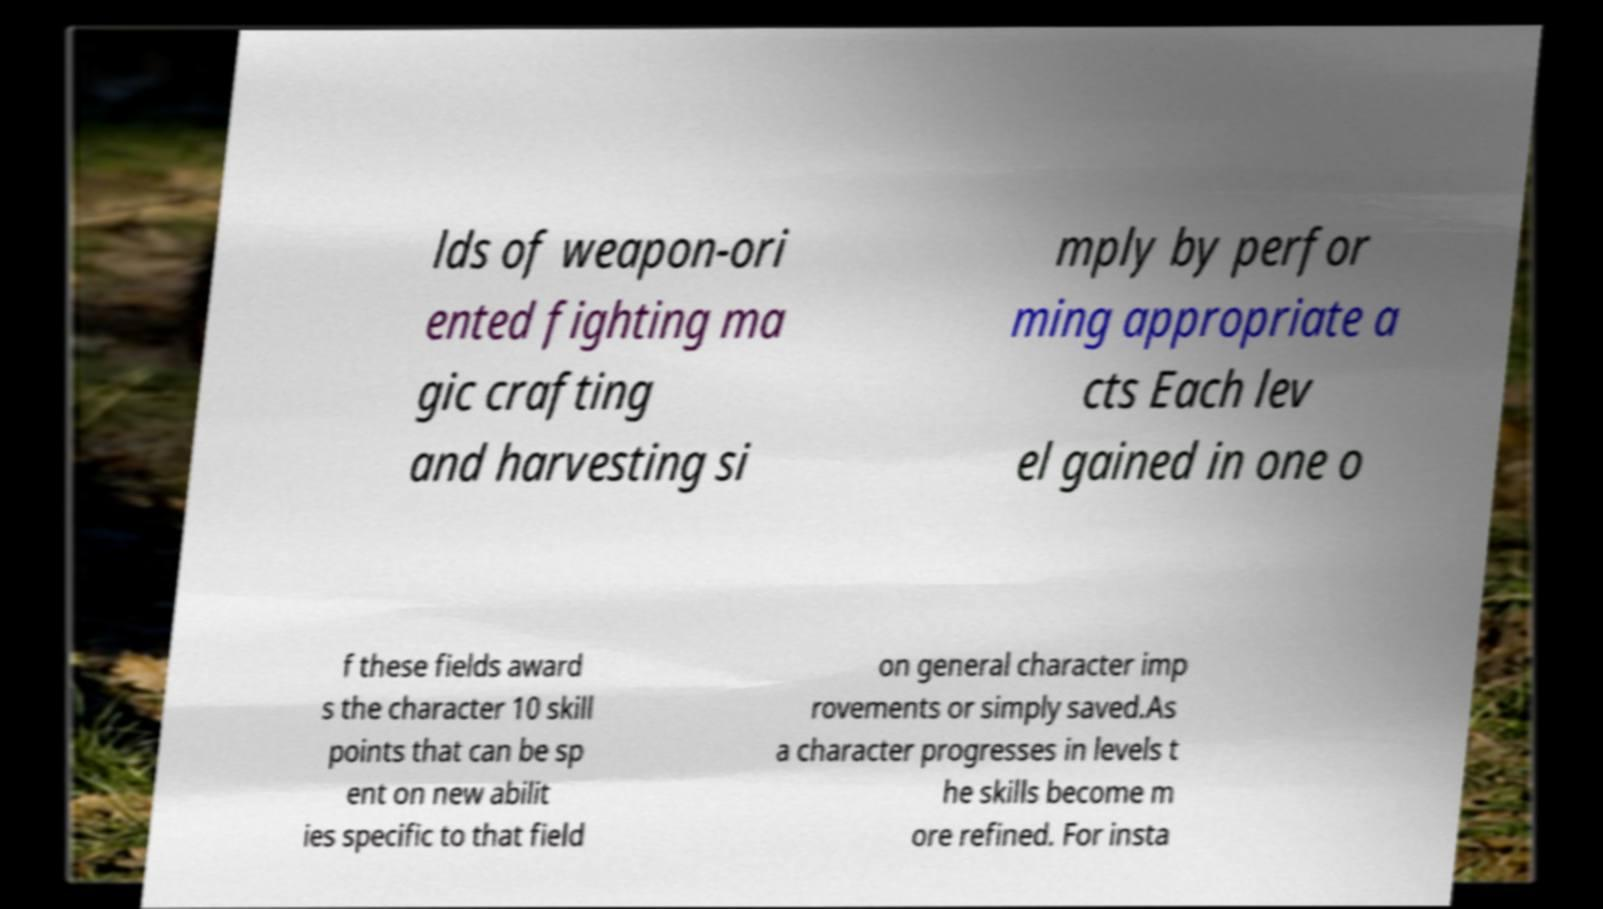Can you read and provide the text displayed in the image?This photo seems to have some interesting text. Can you extract and type it out for me? lds of weapon-ori ented fighting ma gic crafting and harvesting si mply by perfor ming appropriate a cts Each lev el gained in one o f these fields award s the character 10 skill points that can be sp ent on new abilit ies specific to that field on general character imp rovements or simply saved.As a character progresses in levels t he skills become m ore refined. For insta 